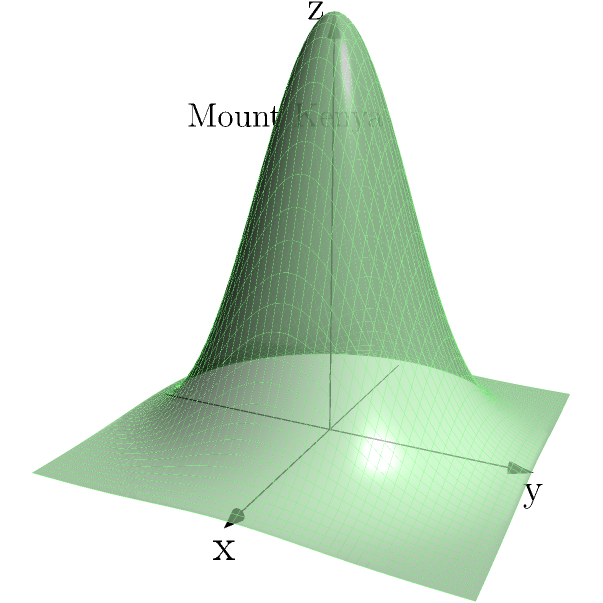As a geography teacher, you want to estimate the volume of Mount Kenya using geometric solids. Given that the base of Mount Kenya can be approximated as a circle with a radius of 25 km and its peak reaches an altitude of 5,199 meters above sea level, estimate its volume assuming it has a conical shape. How does this compare to the actual volume of Mount Kenya, which is estimated to be about 1,200 km³? To estimate the volume of Mount Kenya using a conical approximation, we'll follow these steps:

1. Identify the formula for the volume of a cone:
   $$ V = \frac{1}{3}\pi r^2 h $$
   where $V$ is volume, $r$ is the radius of the base, and $h$ is the height.

2. Convert the given measurements to consistent units:
   Radius (r) = 25 km
   Height (h) = 5.199 km (rounded to 3 decimal places)

3. Substitute the values into the formula:
   $$ V = \frac{1}{3}\pi (25\text{ km})^2 (5.199\text{ km}) $$

4. Calculate:
   $$ V = \frac{1}{3}\pi (625) (5.199) \approx 3,402.87\text{ km}^3 $$

5. Compare to the actual volume:
   Estimated volume: 3,402.87 km³
   Actual volume: 1,200 km³

6. Calculate the difference:
   $$ 3,402.87\text{ km}^3 - 1,200\text{ km}^3 = 2,202.87\text{ km}^3 $$

7. Calculate the percentage overestimation:
   $$ \frac{2,202.87}{1,200} \times 100\% \approx 183.57\% $$

The conical approximation overestimates the volume by about 183.57%. This significant difference is due to the simplification of the mountain's shape. In reality, Mount Kenya has a more complex profile with varying slopes and irregularities that reduce its actual volume compared to a perfect cone.
Answer: The conical approximation yields 3,402.87 km³, overestimating by 183.57% compared to the actual 1,200 km³ volume. 